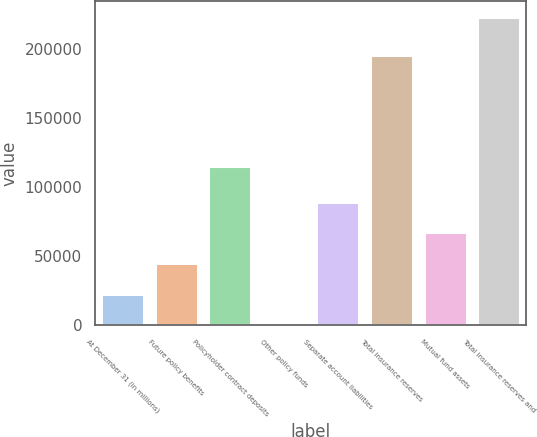<chart> <loc_0><loc_0><loc_500><loc_500><bar_chart><fcel>At December 31 (in millions)<fcel>Future policy benefits<fcel>Policyholder contract deposits<fcel>Other policy funds<fcel>Separate account liabilities<fcel>Total insurance reserves<fcel>Mutual fund assets<fcel>Total insurance reserves and<nl><fcel>22720.7<fcel>45043.4<fcel>115575<fcel>398<fcel>89688.8<fcel>195890<fcel>67366.1<fcel>223625<nl></chart> 